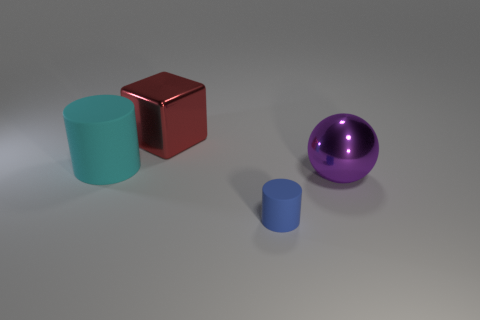Add 1 big metallic balls. How many objects exist? 5 Subtract all blocks. How many objects are left? 3 Add 2 tiny red rubber spheres. How many tiny red rubber spheres exist? 2 Subtract 1 cyan cylinders. How many objects are left? 3 Subtract all green matte blocks. Subtract all matte things. How many objects are left? 2 Add 4 small things. How many small things are left? 5 